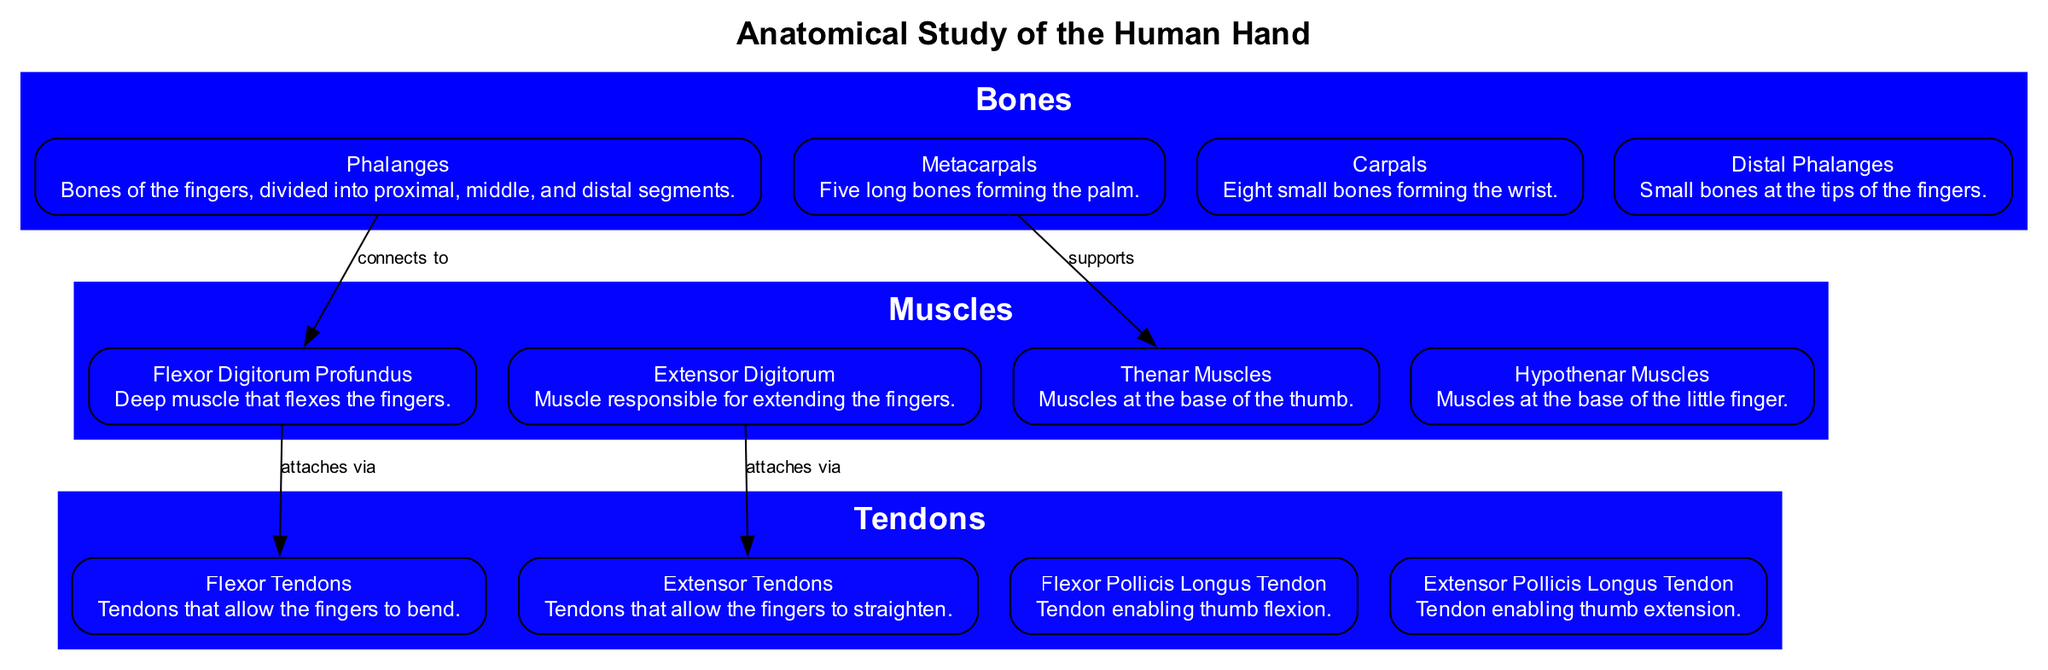What are the bones of the fingers called? The diagram labels the bones of the fingers as "Phalanges." By inspecting the section pertaining to bones, we can find that it specifically defines the Phalanges as the bones that compose the fingers, including proximal, middle, and distal segments.
Answer: Phalanges How many types of muscles are listed in the diagram? The diagram categorizes muscles relevant for realistic drawing into four types: Flexor Digitorum Profundus, Extensor Digitorum, Thenar Muscles, and Hypothenar Muscles. By counting each listed muscle within the 'Muscles' section, we arrive at the total number.
Answer: 4 What type of tendon enables thumb extension? By referring to the tendons depicted in the diagram, we pinpoint the "Extensor Pollicis Longus Tendon," which is explicitly labeled as the tendon that allows for the extension of the thumb.
Answer: Extensor Pollicis Longus Tendon Which bones support the Thenar Muscles? The diagram indicates that Metacarpals provide support for the Thenar Muscles, based on the labeled connection in the edges drawn within the graph, linking the Metacarpals to the Thenar Muscles.
Answer: Metacarpals Identify a muscle that flexes the fingers. The diagram identifies the "Flexor Digitorum Profundus" as a muscle involved in finger flexion. This information is directly pulled from the muscle section that explicitly describes this muscle's function.
Answer: Flexor Digitorum Profundus What connects the Phalanges to the Flexor Digitorum Profundus? The diagram outlines the connection labeled "connects to" that links Phalanges to the Flexor Digitorum Profundus, indicating a direct anatomical relationship between these points.
Answer: connects to How many carpal bones are there? According to the diagram, there are eight small bones that make up the carpal section, as listed under the 'Bones' section pertaining to the human hand anatomy.
Answer: 8 What is the role of Flexor Tendons in the hand? Based on the diagram, the role of the Flexor Tendons is stated as enabling the fingers to bend, which is detailed in the information provided about these tendons in the Tendons section.
Answer: allow fingers to bend 